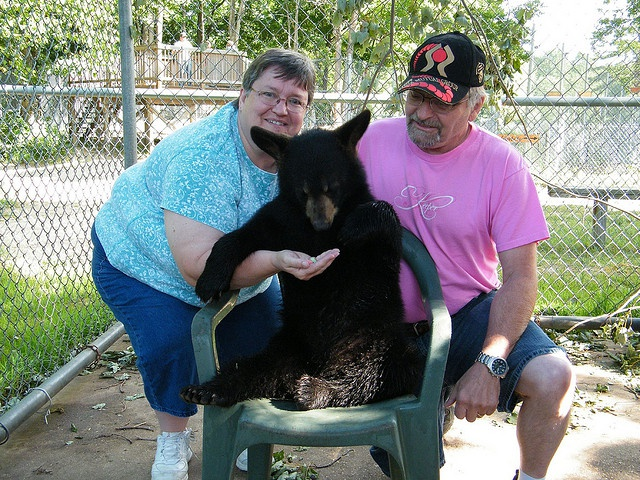Describe the objects in this image and their specific colors. I can see people in tan, magenta, black, and gray tones, bear in tan, black, gray, and darkgray tones, people in tan, navy, lightblue, and darkgray tones, chair in tan, black, teal, gray, and darkgray tones, and people in tan, white, darkgray, and gray tones in this image. 